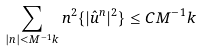<formula> <loc_0><loc_0><loc_500><loc_500>\sum _ { | n | < M ^ { - 1 } k } { n ^ { 2 } \{ | \hat { u } ^ { n } | ^ { 2 } \} } \leq C M ^ { - 1 } k</formula> 